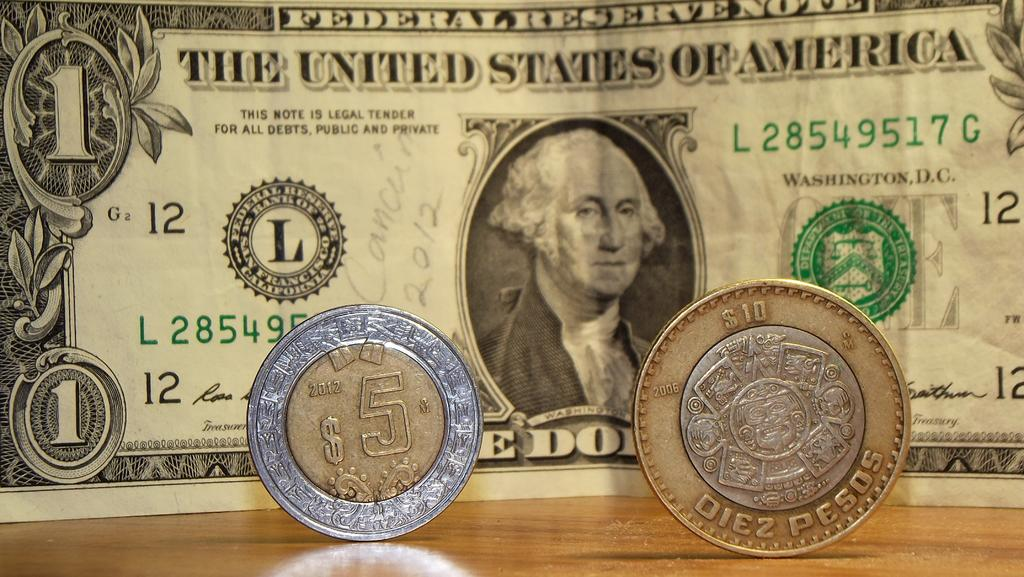<image>
Describe the image concisely. United States paper currency is being displayed behind pesos. 